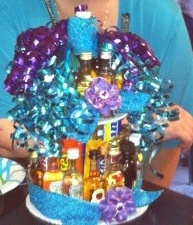Describe the objects in this image and their specific colors. I can see people in lightblue, teal, and tan tones, dining table in lightblue, black, and gray tones, bottle in lightblue, gray, and white tones, bottle in lightblue, brown, orange, and maroon tones, and bottle in lightblue, gray, khaki, and tan tones in this image. 